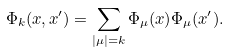<formula> <loc_0><loc_0><loc_500><loc_500>\Phi _ { k } ( x , x ^ { \prime } ) = \sum _ { | \mu | = k } \Phi _ { \mu } ( x ) \Phi _ { \mu } ( x ^ { \prime } ) .</formula> 